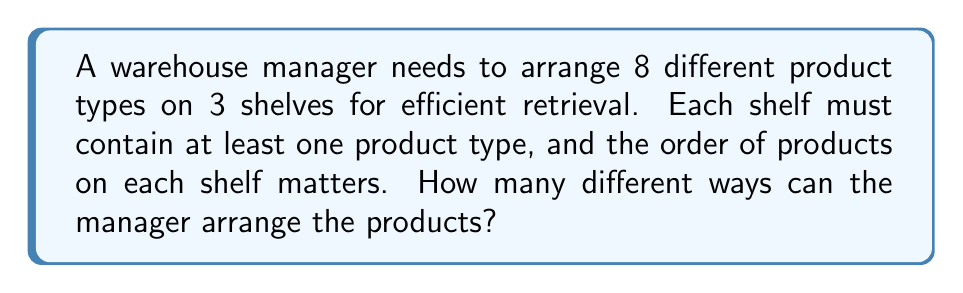Could you help me with this problem? Let's approach this step-by-step:

1) This is a problem of distributing distinct objects (8 product types) into distinct boxes (3 shelves) where the order matters and each box must contain at least one object. This is a case of Stirling numbers of the second kind combined with permutations.

2) Let $S(8,k)$ represent the Stirling number of the second kind for 8 objects distributed into k non-empty subsets.

3) We need to consider all possible distributions where k = 1, 2, and 3:

   For k = 1: $S(8,1) = 1$ way
   For k = 2: $S(8,2)$ ways
   For k = 3: $S(8,3)$ ways

4) For each of these distributions, we need to consider:
   a) The number of ways to assign these k groups to 3 shelves: $P(3,k) = \frac{3!}{(3-k)!}$
   b) The number of ways to arrange products within each shelf: $k!$

5) Therefore, the total number of arrangements is:

   $$\sum_{k=1}^3 S(8,k) \cdot P(3,k) \cdot k!$$

6) Calculating each term:
   For k = 1: $1 \cdot 3 \cdot 1 = 3$
   For k = 2: $S(8,2) \cdot 6 \cdot 2$
   For k = 3: $S(8,3) \cdot 6 \cdot 6$

7) The Stirling numbers $S(8,2)$ and $S(8,3)$ can be calculated:
   $S(8,2) = 127$
   $S(8,3) = 966$

8) Substituting these values:
   $3 + (127 \cdot 6 \cdot 2) + (966 \cdot 6 \cdot 6) = 3 + 1,524 + 34,776 = 36,303$

Therefore, there are 36,303 different ways to arrange the products.
Answer: 36,303 